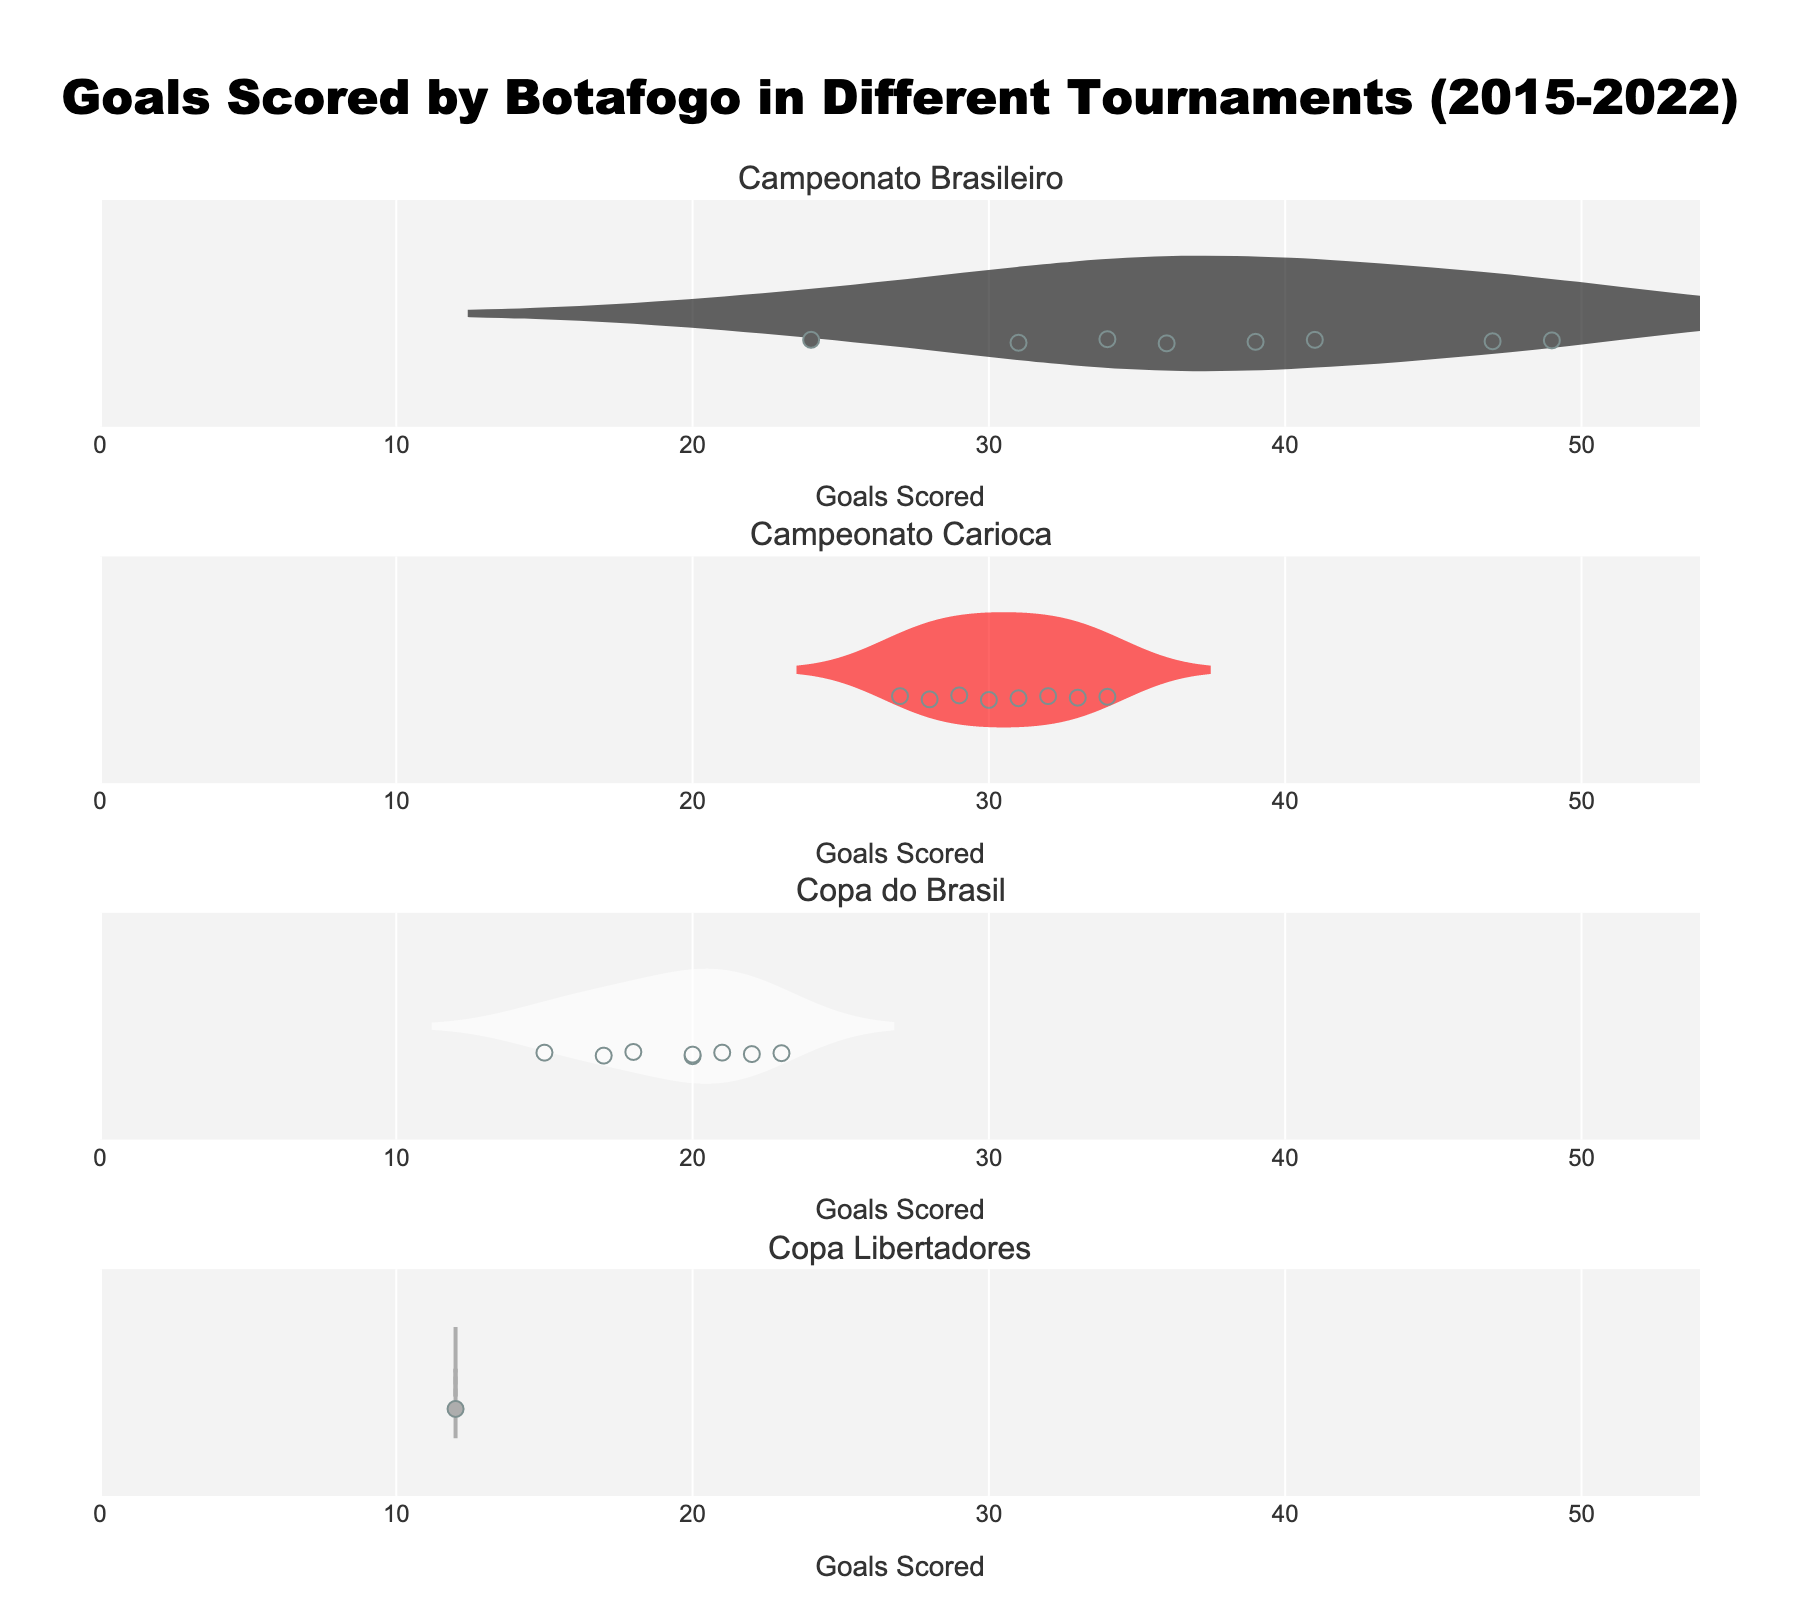How many tournaments are analyzed in the figure? The figure presents a separate subplot for each tournament Botafogo has participated in from 2015 to 2022, which are named in the subplot titles.
Answer: 4 What is the title of the figure? The title is a large text located at the top of the figure and provides an overview of the contents.
Answer: "Goals Scored by Botafogo in Different Tournaments (2015-2022)" Which tournament has the highest median number of goals scored? The median is indicated by the mean line inside each violin plot, and comparing these across all subplots reveals the highest.
Answer: Campeonato Brasileiro What is the least number of goals scored in any tournament? Identify the smallest value point present in any of the violin plots across all tournaments.
Answer: 12 On which axis are the goals scores displayed? The goals scored are plotted horizontally across all subplots, indicating they are displayed on the x-axis.
Answer: x-axis Which tournament shows the most variability in goals scored? Variability can be determined by the width and spread of the violin plot. The wider and more spread out the plot, the more variability it shows.
Answer: Campeonato Brasileiro What is the average number of goals scored in Campeonato Carioca across all years? To find the average, sum the goals scored in all years within Campeonato Carioca and divide by the number of years (data points).
Answer: (32 + 29 + 33 + 30 + 28 + 27 + 31 + 34)/8 = 30.5 In Campeonato Brasileiro, in which year did Botafogo score the fewest goals? Identify the smallest data point within the Campeonato Brasileiro sub-plot, and note the corresponding year from the data.
Answer: 2020 How many goals did Botafogo score in the Copa do Brasil in 2022? Locate the specific data point corresponding to the year 2022 within the Copa do Brasil subplot.
Answer: 23 Compare the goals scored in Campeonato Brasileiro in 2015 and 2022, which year had higher goals scored? Look at the data points for Campeonato Brasileiro for the years 2015 and 2022 and compare their values.
Answer: 2015 